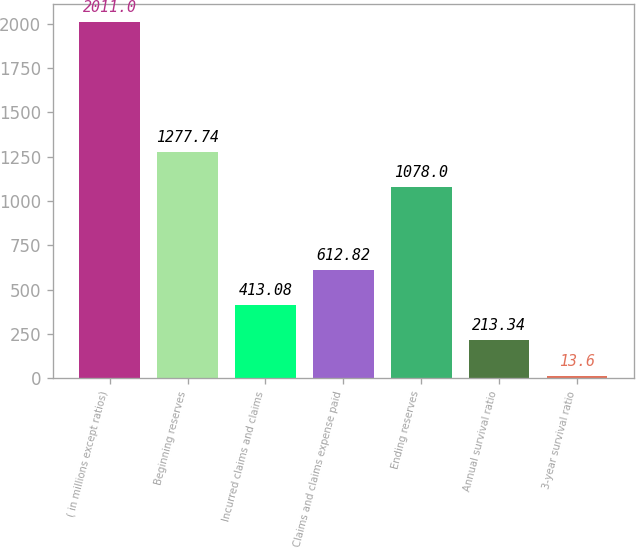<chart> <loc_0><loc_0><loc_500><loc_500><bar_chart><fcel>( in millions except ratios)<fcel>Beginning reserves<fcel>Incurred claims and claims<fcel>Claims and claims expense paid<fcel>Ending reserves<fcel>Annual survival ratio<fcel>3-year survival ratio<nl><fcel>2011<fcel>1277.74<fcel>413.08<fcel>612.82<fcel>1078<fcel>213.34<fcel>13.6<nl></chart> 